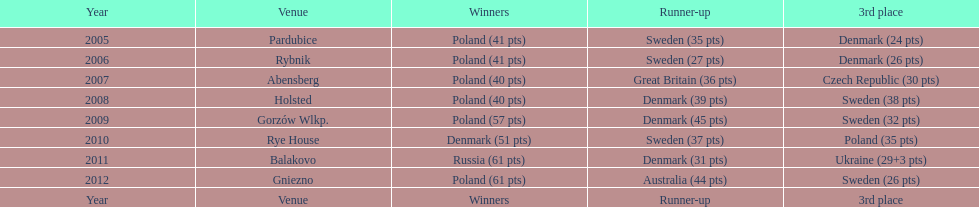In the 2010 championship, did holland emerge as the winner? Rye House. If they didn't, who was the champion and at which position did holland finish? 3rd place. 